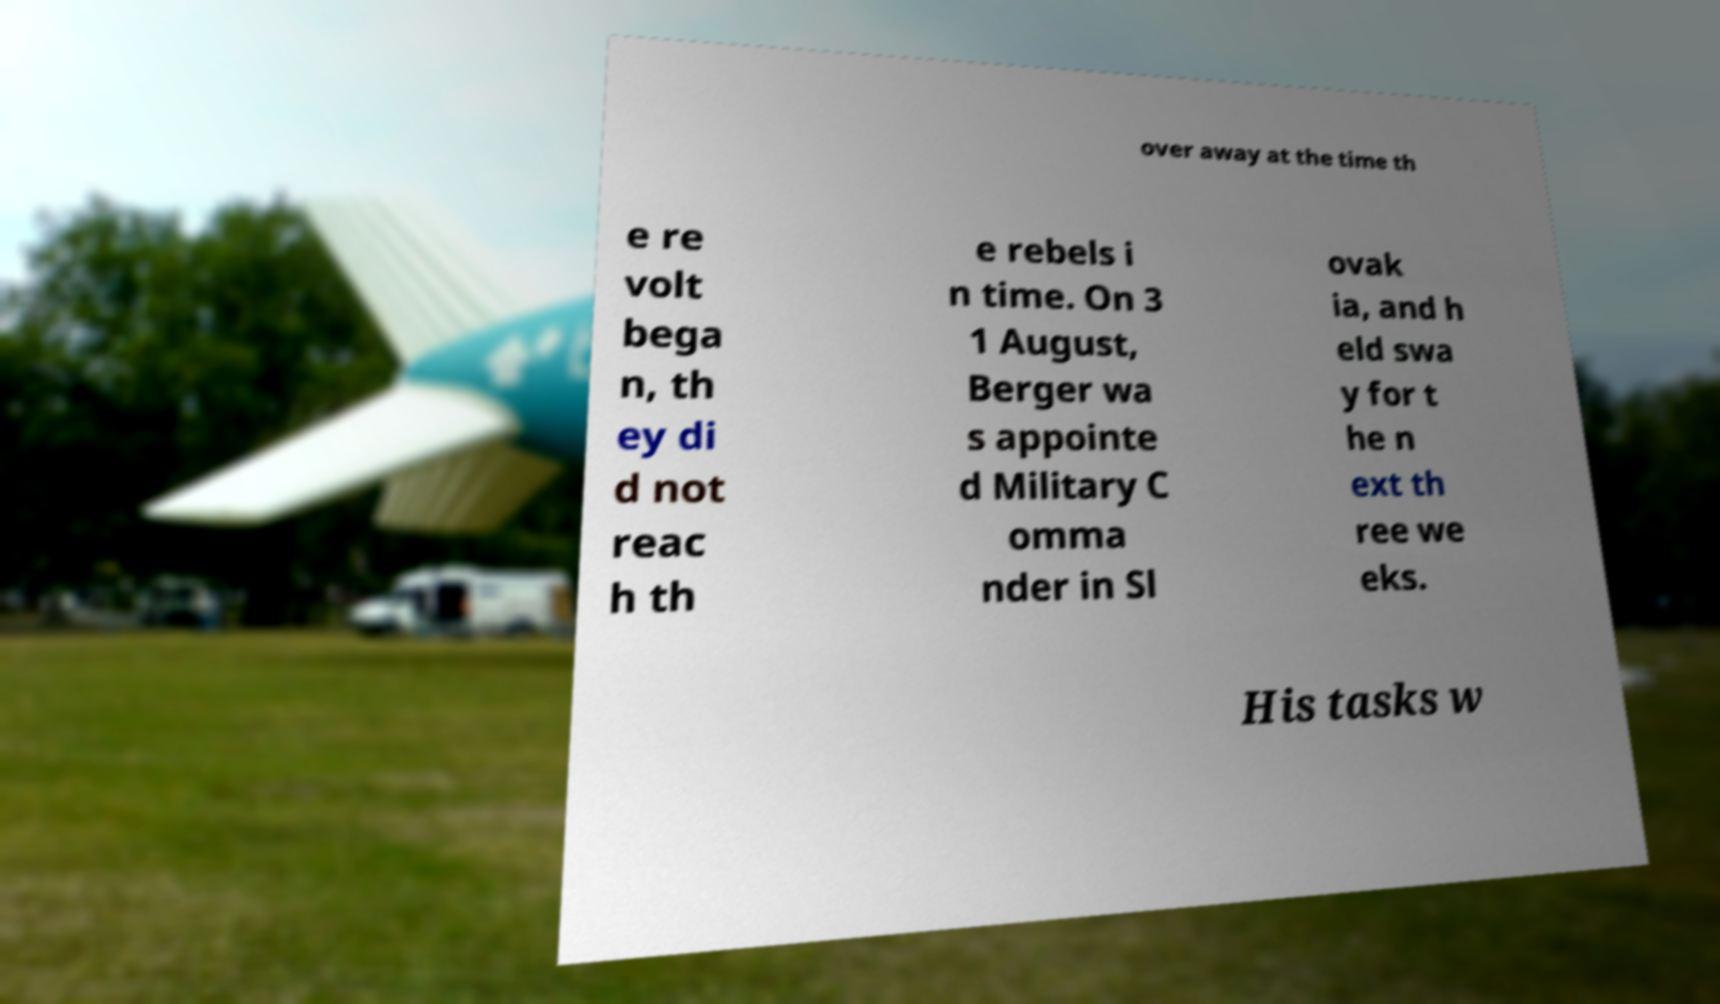Could you assist in decoding the text presented in this image and type it out clearly? over away at the time th e re volt bega n, th ey di d not reac h th e rebels i n time. On 3 1 August, Berger wa s appointe d Military C omma nder in Sl ovak ia, and h eld swa y for t he n ext th ree we eks. His tasks w 